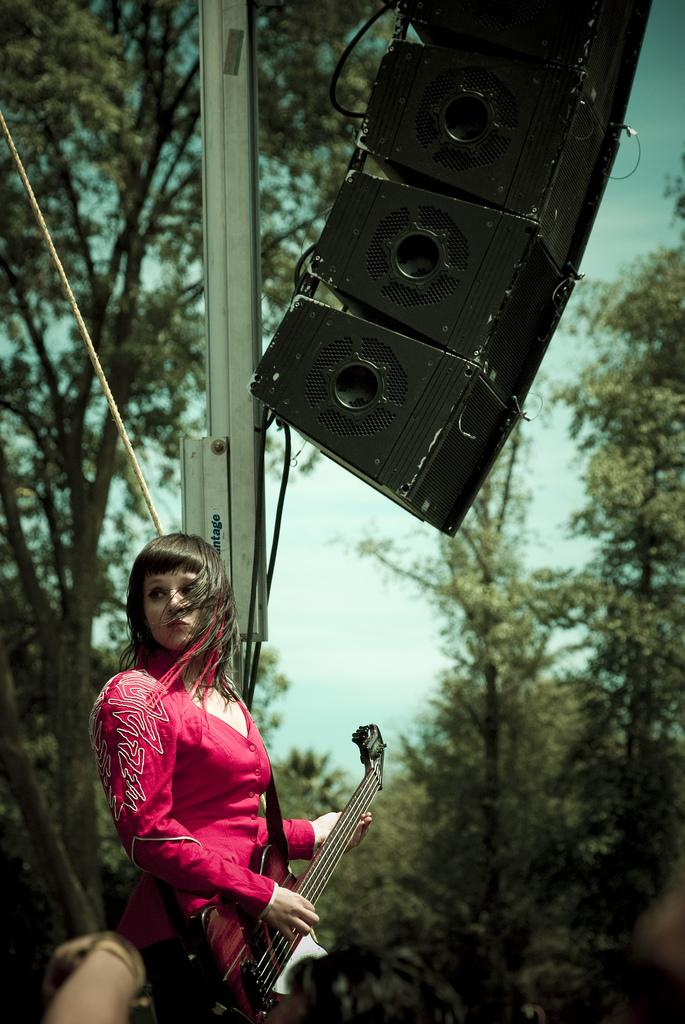What is the woman in the image doing? The woman is playing a guitar in the image. What can be seen in the background of the image? There are trees visible in the image. What type of thread is the woman using to play the guitar in the image? There is no thread involved in playing the guitar in the image. The woman is using her hands to strum the strings. 